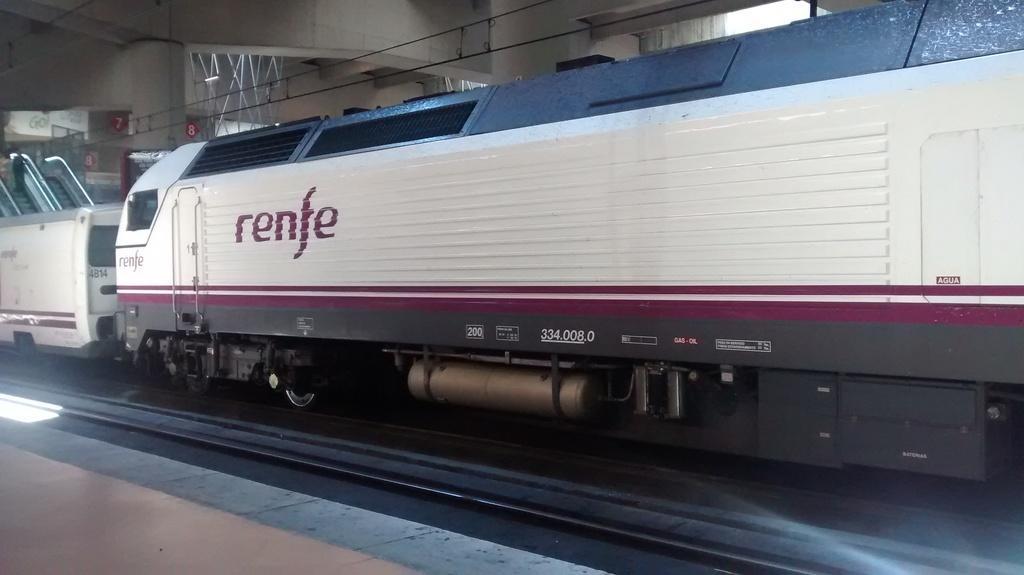Can you describe this image briefly? There is a train on a railway track as we can see in the middle of this image and there is a platform at the bottom of this image. 